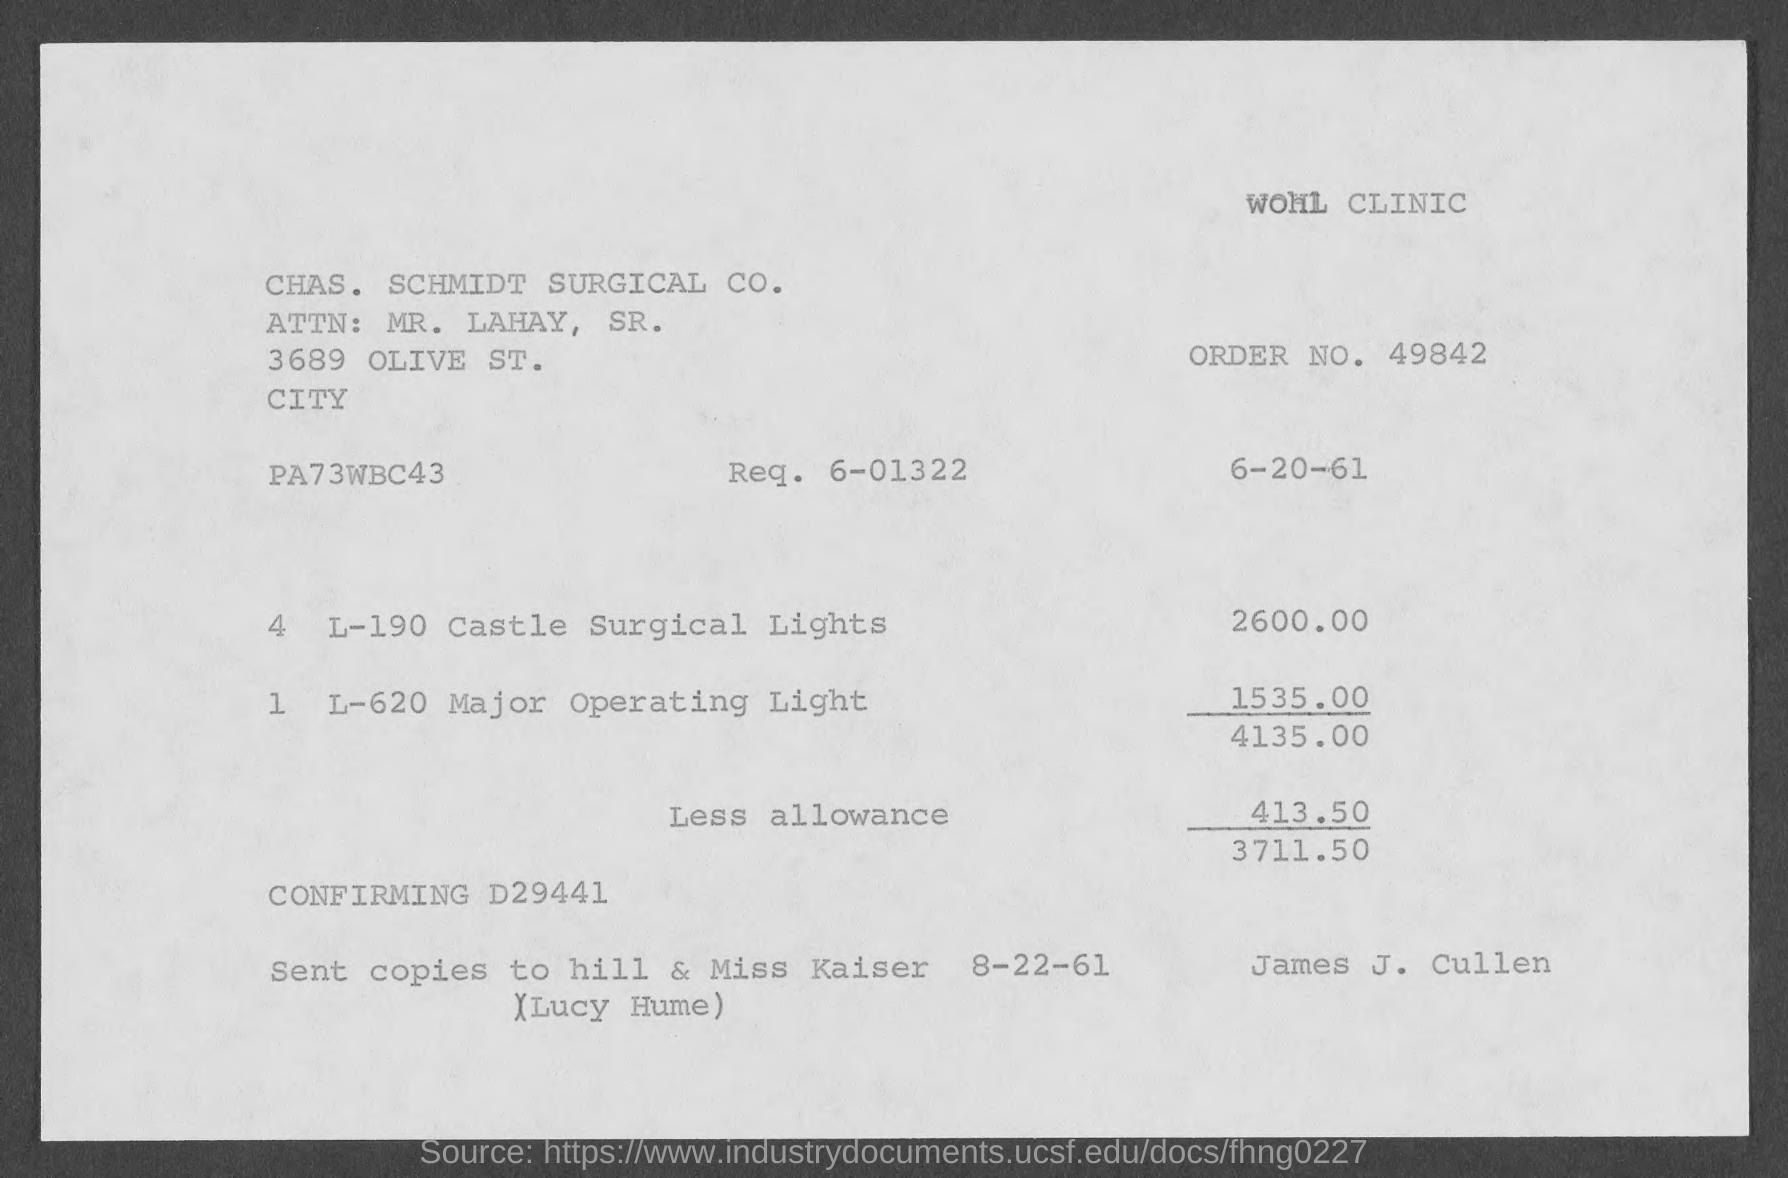What is the order no. mentioned in the given page ?
Provide a short and direct response. 49842. What is the req. no. mentioned in the given page ?
Offer a terse response. 6-01322. What is the amount for castle surgical lights as mentioned in the given page ?
Your response must be concise. 2600.00. What is the amount for major operating light mentioned in the given page ?
Offer a terse response. 1535.00. What is the amount of less allowance mentioned in the given page ?
Keep it short and to the point. 413.50. 